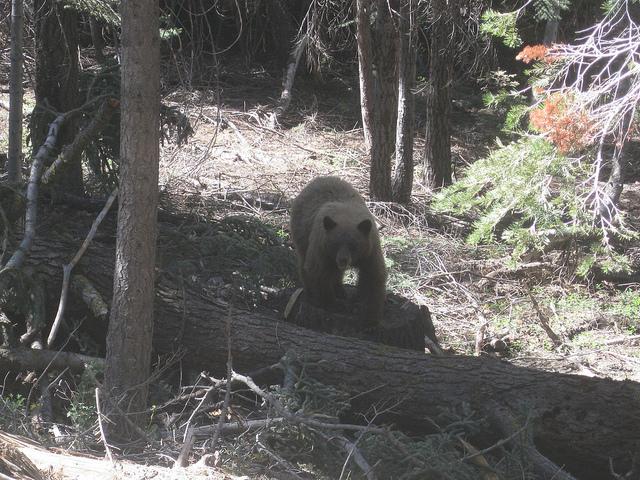What animal is shown in the picture?
Concise answer only. Bear. What does this animal eat?
Short answer required. Fish. Is this animal young or old?
Concise answer only. Young. 